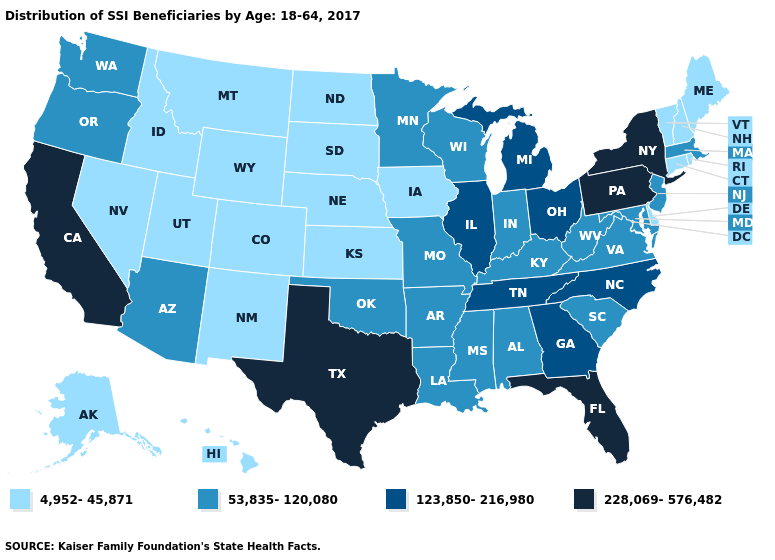What is the lowest value in states that border Nebraska?
Give a very brief answer. 4,952-45,871. What is the highest value in the Northeast ?
Keep it brief. 228,069-576,482. Among the states that border Wisconsin , does Minnesota have the highest value?
Keep it brief. No. What is the value of North Carolina?
Be succinct. 123,850-216,980. Among the states that border Texas , does Arkansas have the highest value?
Be succinct. Yes. Name the states that have a value in the range 4,952-45,871?
Quick response, please. Alaska, Colorado, Connecticut, Delaware, Hawaii, Idaho, Iowa, Kansas, Maine, Montana, Nebraska, Nevada, New Hampshire, New Mexico, North Dakota, Rhode Island, South Dakota, Utah, Vermont, Wyoming. Does the first symbol in the legend represent the smallest category?
Write a very short answer. Yes. Name the states that have a value in the range 123,850-216,980?
Be succinct. Georgia, Illinois, Michigan, North Carolina, Ohio, Tennessee. Among the states that border Louisiana , does Texas have the highest value?
Give a very brief answer. Yes. Does the map have missing data?
Keep it brief. No. What is the value of California?
Answer briefly. 228,069-576,482. Name the states that have a value in the range 228,069-576,482?
Be succinct. California, Florida, New York, Pennsylvania, Texas. Does Texas have the highest value in the South?
Short answer required. Yes. Name the states that have a value in the range 53,835-120,080?
Short answer required. Alabama, Arizona, Arkansas, Indiana, Kentucky, Louisiana, Maryland, Massachusetts, Minnesota, Mississippi, Missouri, New Jersey, Oklahoma, Oregon, South Carolina, Virginia, Washington, West Virginia, Wisconsin. What is the value of Florida?
Short answer required. 228,069-576,482. 